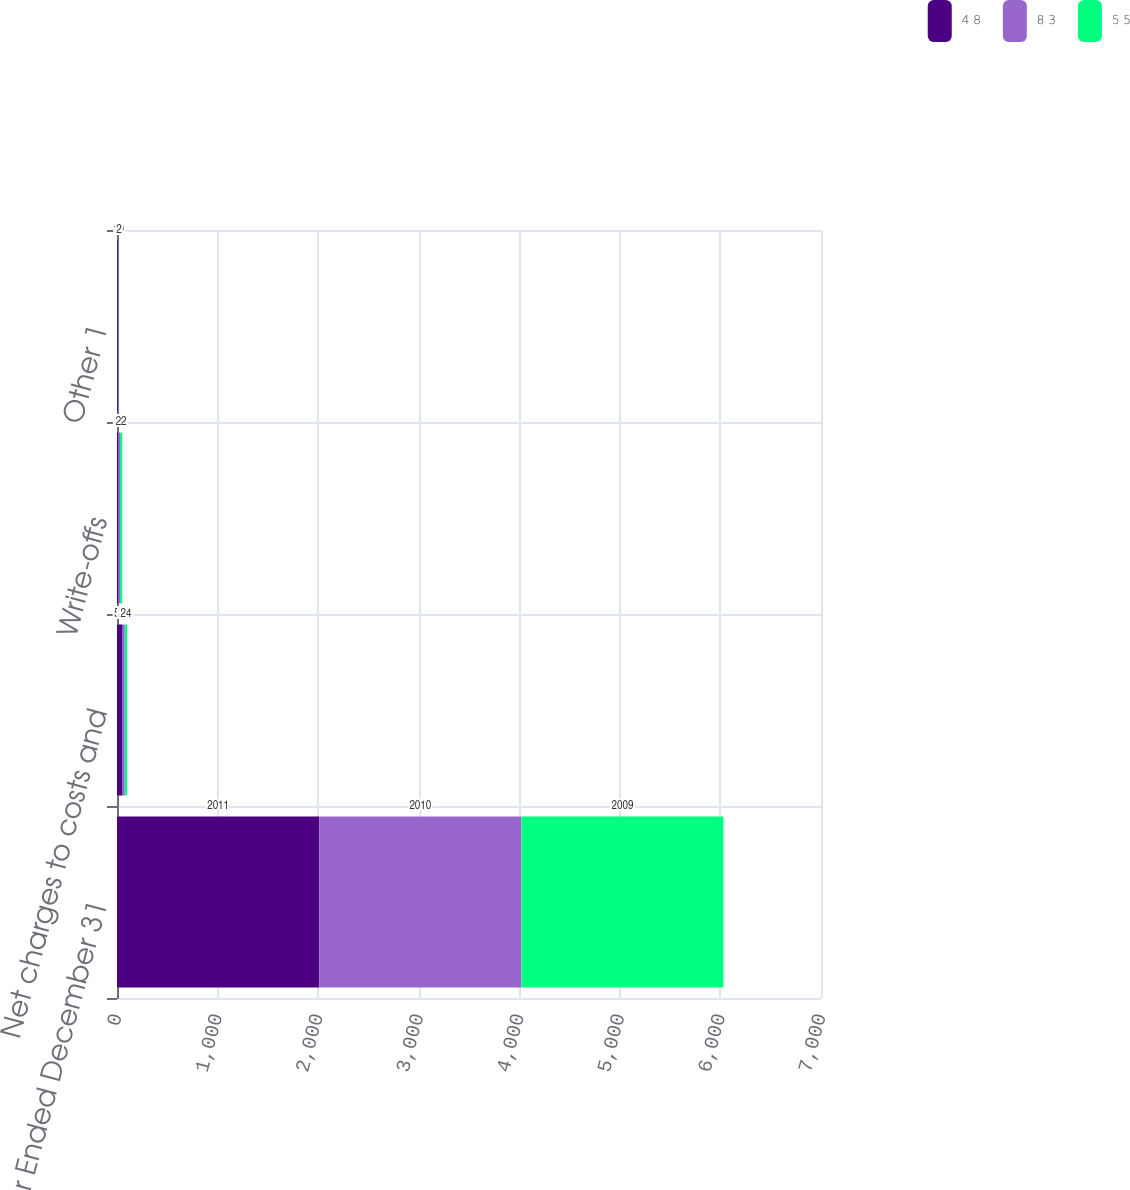<chart> <loc_0><loc_0><loc_500><loc_500><stacked_bar_chart><ecel><fcel>Year Ended December 31<fcel>Net charges to costs and<fcel>Write-offs<fcel>Other 1<nl><fcel>4 8<fcel>2011<fcel>56<fcel>12<fcel>9<nl><fcel>8 3<fcel>2010<fcel>21<fcel>18<fcel>10<nl><fcel>5 5<fcel>2009<fcel>24<fcel>22<fcel>2<nl></chart> 